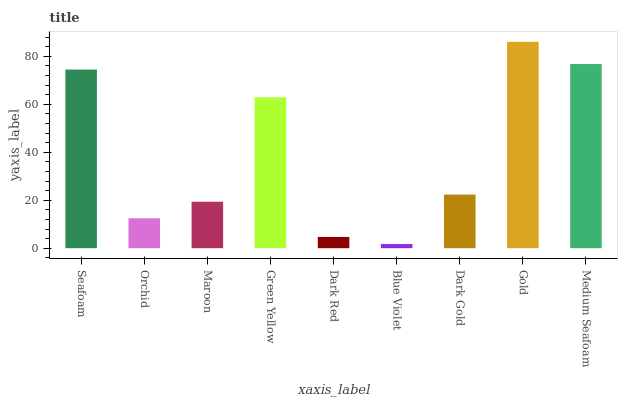Is Blue Violet the minimum?
Answer yes or no. Yes. Is Gold the maximum?
Answer yes or no. Yes. Is Orchid the minimum?
Answer yes or no. No. Is Orchid the maximum?
Answer yes or no. No. Is Seafoam greater than Orchid?
Answer yes or no. Yes. Is Orchid less than Seafoam?
Answer yes or no. Yes. Is Orchid greater than Seafoam?
Answer yes or no. No. Is Seafoam less than Orchid?
Answer yes or no. No. Is Dark Gold the high median?
Answer yes or no. Yes. Is Dark Gold the low median?
Answer yes or no. Yes. Is Seafoam the high median?
Answer yes or no. No. Is Orchid the low median?
Answer yes or no. No. 